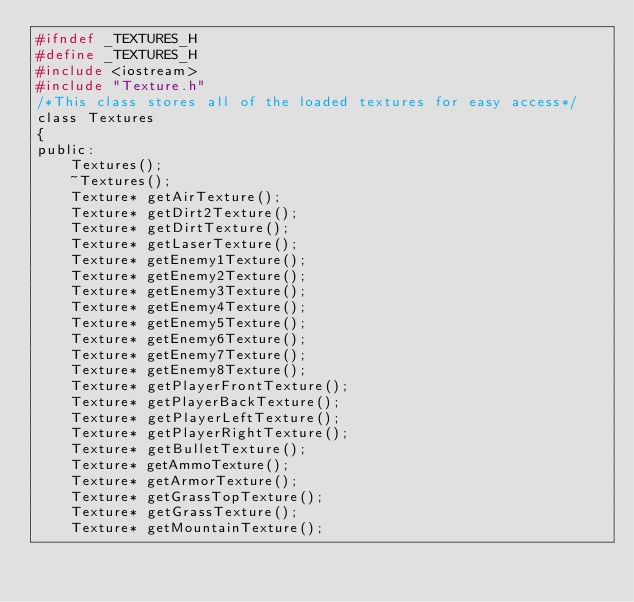Convert code to text. <code><loc_0><loc_0><loc_500><loc_500><_C_>#ifndef _TEXTURES_H
#define _TEXTURES_H
#include <iostream>
#include "Texture.h"
/*This class stores all of the loaded textures for easy access*/
class Textures
{
public:
	Textures();
	~Textures();
	Texture* getAirTexture();
	Texture* getDirt2Texture();
	Texture* getDirtTexture();
	Texture* getLaserTexture();
	Texture* getEnemy1Texture();
	Texture* getEnemy2Texture();
	Texture* getEnemy3Texture();
	Texture* getEnemy4Texture();
	Texture* getEnemy5Texture();
	Texture* getEnemy6Texture();
	Texture* getEnemy7Texture();
	Texture* getEnemy8Texture();
	Texture* getPlayerFrontTexture();
	Texture* getPlayerBackTexture();
	Texture* getPlayerLeftTexture();
	Texture* getPlayerRightTexture();
	Texture* getBulletTexture();
	Texture* getAmmoTexture();
	Texture* getArmorTexture();
	Texture* getGrassTopTexture();
	Texture* getGrassTexture();
	Texture* getMountainTexture();</code> 